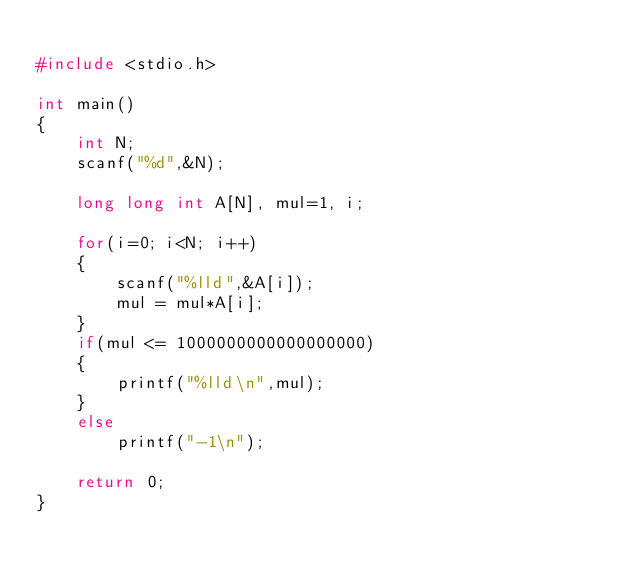Convert code to text. <code><loc_0><loc_0><loc_500><loc_500><_C_>
#include <stdio.h>

int main()
{
    int N;
    scanf("%d",&N);

    long long int A[N], mul=1, i;

    for(i=0; i<N; i++)
    {
        scanf("%lld",&A[i]);
        mul = mul*A[i];
    }
    if(mul <= 1000000000000000000)
    {
        printf("%lld\n",mul);
    }
    else
        printf("-1\n");

    return 0;
}
</code> 